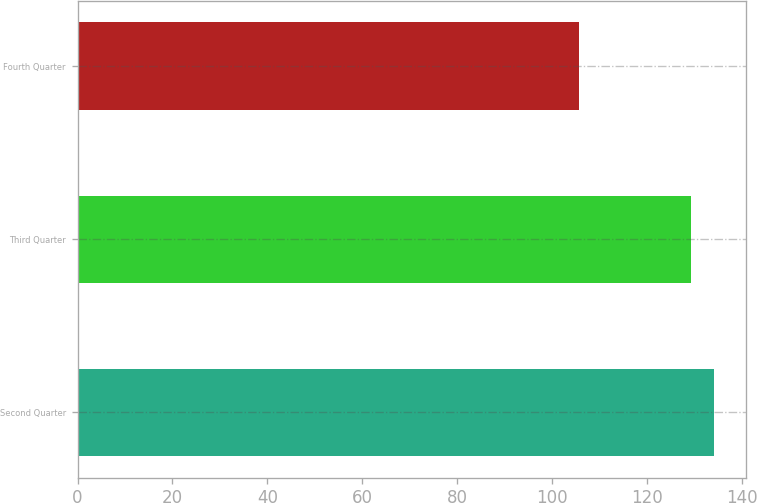Convert chart to OTSL. <chart><loc_0><loc_0><loc_500><loc_500><bar_chart><fcel>Second Quarter<fcel>Third Quarter<fcel>Fourth Quarter<nl><fcel>134.13<fcel>129.26<fcel>105.64<nl></chart> 